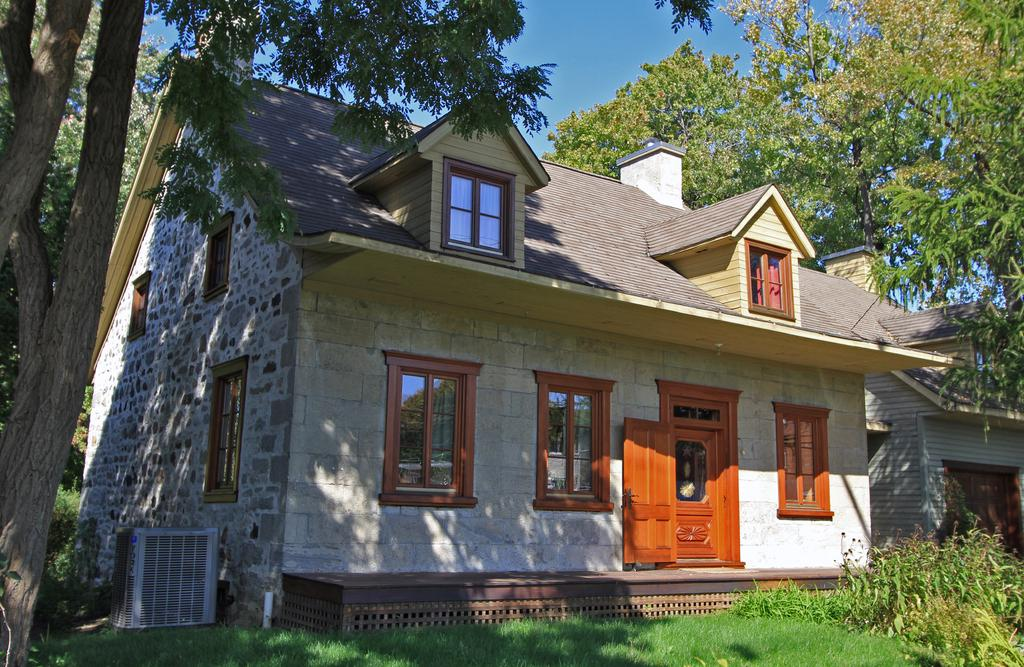What is the main structure in the center of the image? There is a house in the center of the image. What type of vegetation can be seen at the bottom of the image? Grass and plants are visible at the bottom of the image. What can be seen in the background of the image? There are trees and the sky visible in the background of the image. How many parts of a chess set can be seen in the image? There are no parts of a chess set present in the image. Is the house in the image sleeping? The house in the image is an inanimate object and cannot sleep. 